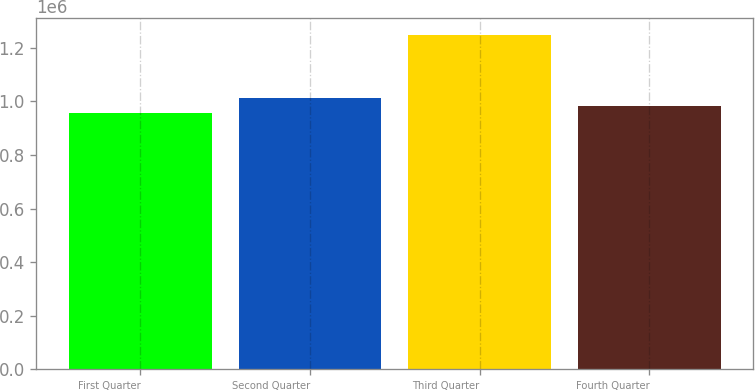Convert chart to OTSL. <chart><loc_0><loc_0><loc_500><loc_500><bar_chart><fcel>First Quarter<fcel>Second Quarter<fcel>Third Quarter<fcel>Fourth Quarter<nl><fcel>955145<fcel>1.01401e+06<fcel>1.24945e+06<fcel>984576<nl></chart> 